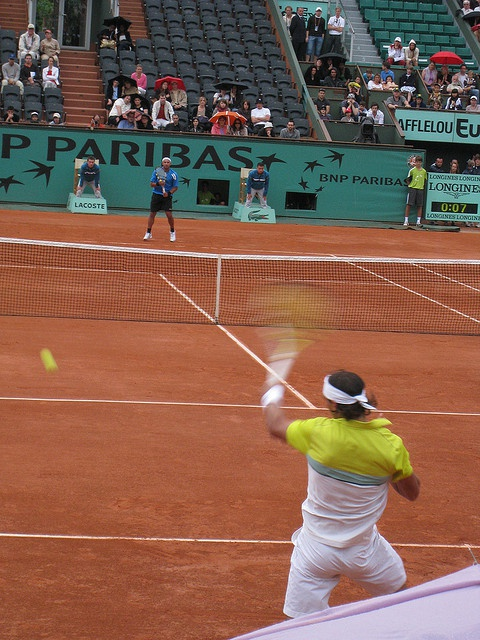Describe the objects in this image and their specific colors. I can see people in maroon, black, gray, and teal tones, people in maroon, darkgray, brown, olive, and lavender tones, tennis racket in maroon, salmon, brown, tan, and darkgray tones, people in maroon, black, navy, and blue tones, and people in maroon, black, navy, gray, and blue tones in this image. 